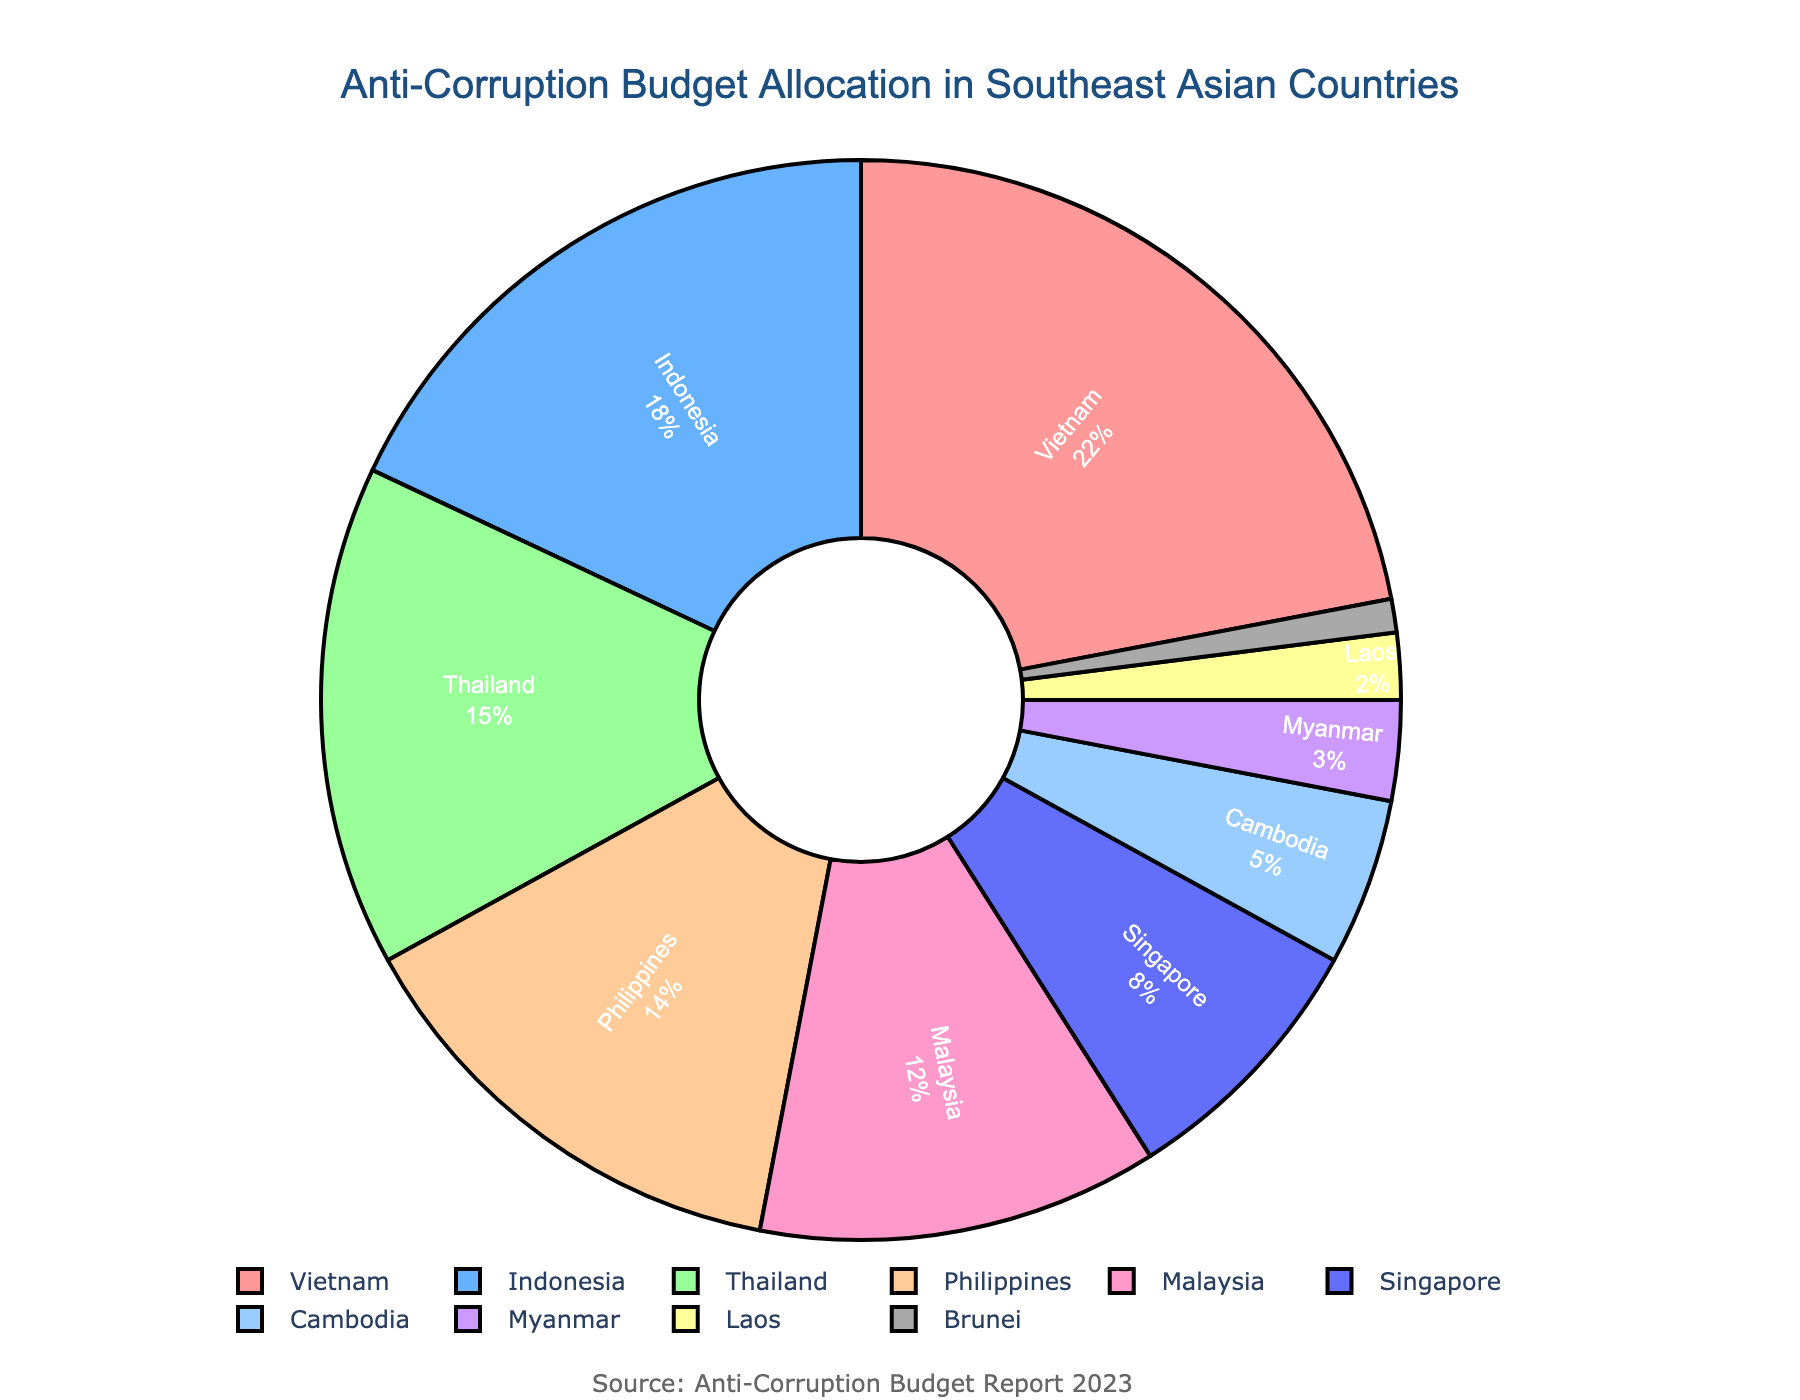What's the largest budget allocation shown in the pie chart? The largest budget allocation can be identified visually by the largest section in the pie chart. The figure shows that Vietnam has the largest allocation at 22%.
Answer: 22% Which country has the second smallest budget allocation? To find the second smallest allocation, first identify the smallest (Brunei, 1%) and then look for the next smallest value, which is Laos with 2%.
Answer: Laos What is the combined budget allocation for Cambodia, Myanmar, Laos, and Brunei? Add the individual allocations for Cambodia (5%), Myanmar (3%), Laos (2%), and Brunei (1%) together: 5 + 3 + 2 + 1 = 11.
Answer: 11% How many countries have a budget allocation greater than 10%? Identify the countries with allocations greater than 10%: Vietnam (22%), Indonesia (18%), Thailand (15%), Philippines (14%), Malaysia (12%). The number of such countries is 5.
Answer: 5 Which country has almost a quarter of the total anti-corruption budget allocation? A quarter of the budget would be around 25%. The country closest to this figure is Vietnam with 22%.
Answer: Vietnam How does Vietnam's budget allocation compare to Thailand's? Compare the allocated percentages for Vietnam (22%) and Thailand (15%). Vietnam's allocation is larger.
Answer: Vietnam's allocation is larger What's the difference in budget allocation between Indonesia and Singapore? Subtract Singapore's allocation (8%) from Indonesia's allocation (18%): 18 - 8 = 10.
Answer: 10% What percentage of the total budget is allocated to countries with an alphabetical first letter  between 'A' and 'M'? Sum allocations for countries from 'A' to 'M' (Vietnam: 22, Indonesia: 18, Thailand: 15, Philippines: 14, Malaysia: 12, Cambodia: 5, Myanmar: 3, Laos: 2): 22 + 18 + 15 + 14 + 12 + 5 + 3 + 2 = 91.
Answer: 91% Are there more countries with budget allocations above or below 10%? Identify countries above 10% (Vietnam, Indonesia, Thailand, Philippines, Malaysia) - 5 countries. Identify countries below 10% (Singapore, Cambodia, Myanmar, Laos, Brunei) - also 5 countries. The numbers are equal.
Answer: Equal What color is used to represent Indonesia in the pie chart? Refer to the pie chart and check the segment labeled “Indonesia”. It is shown in a specific color, which is blue.
Answer: Blue 